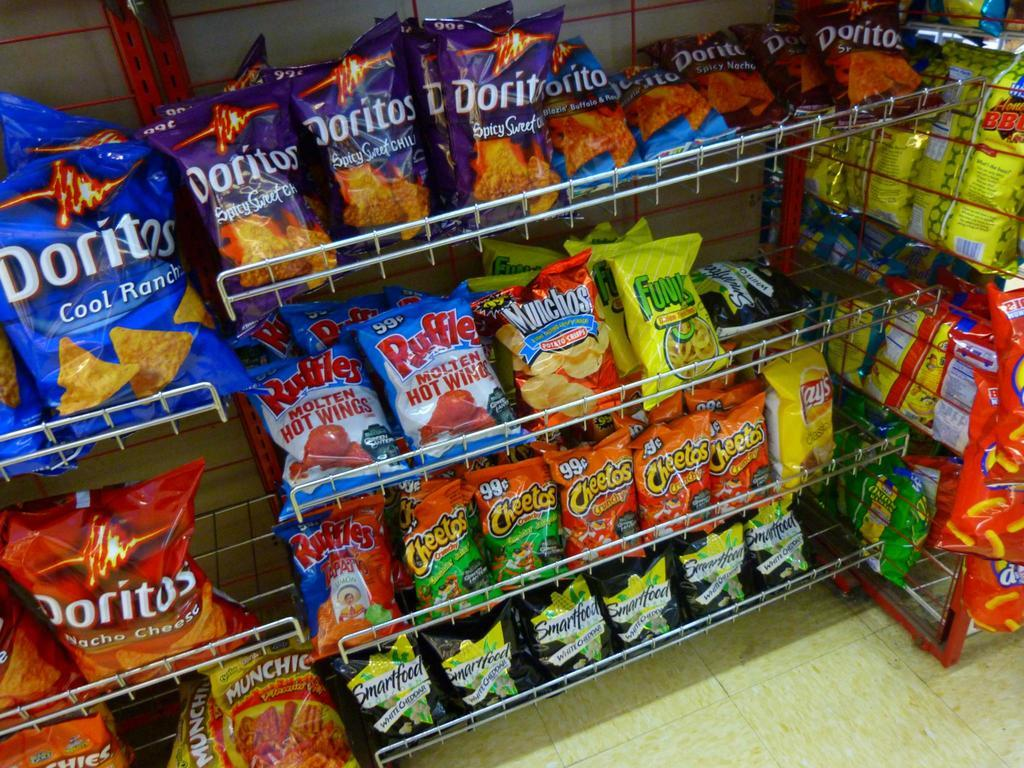<image>
Relay a brief, clear account of the picture shown. Various flavors of Doritos potato chips line the shelves at this store. 